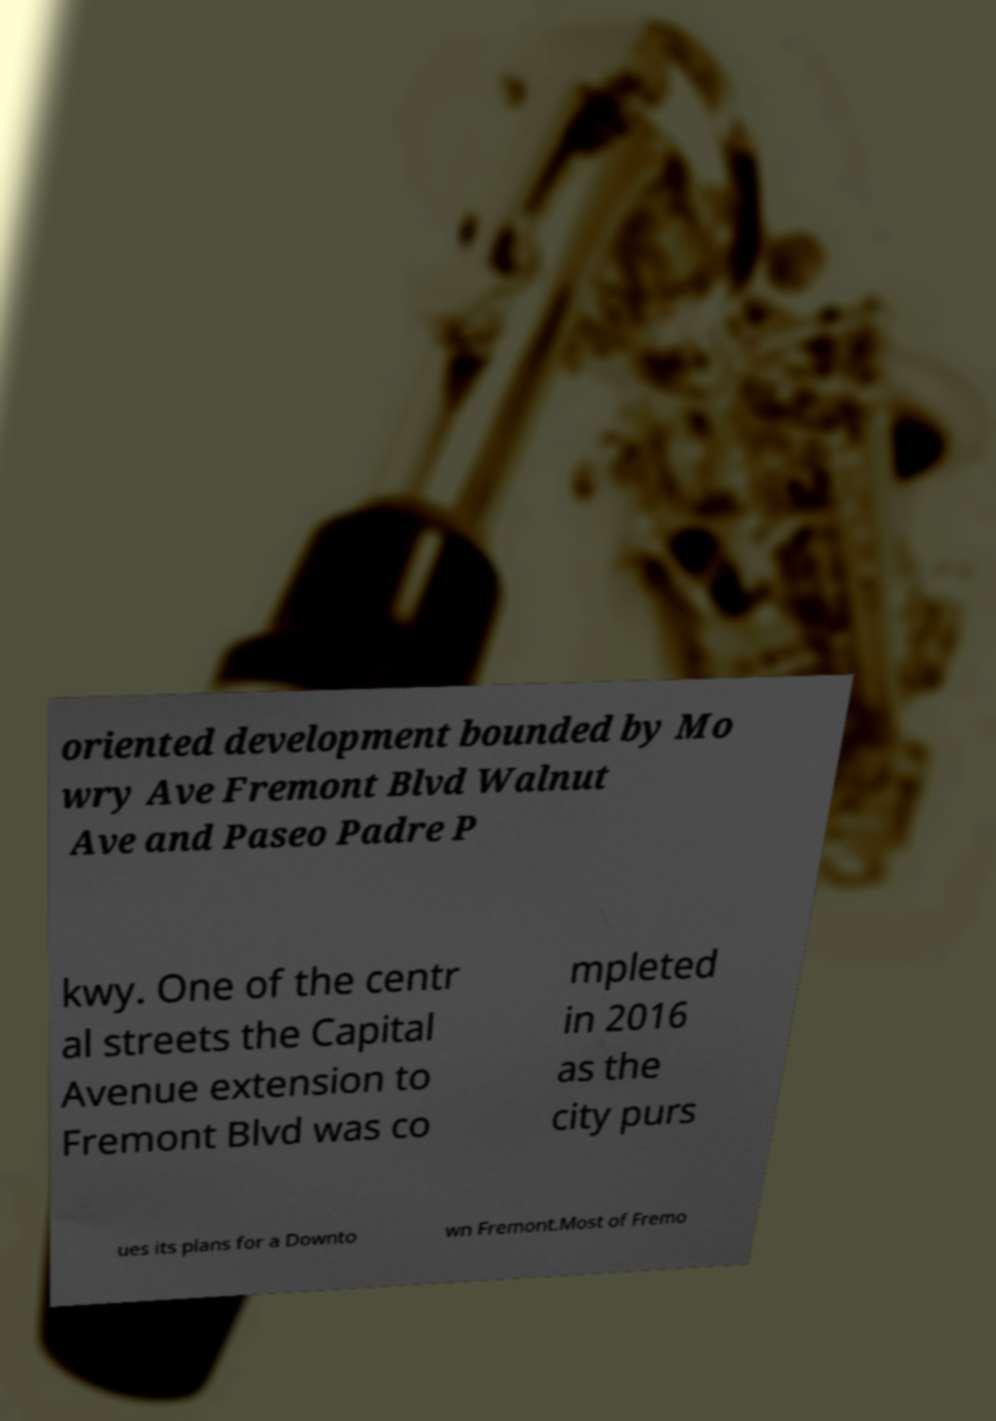What messages or text are displayed in this image? I need them in a readable, typed format. oriented development bounded by Mo wry Ave Fremont Blvd Walnut Ave and Paseo Padre P kwy. One of the centr al streets the Capital Avenue extension to Fremont Blvd was co mpleted in 2016 as the city purs ues its plans for a Downto wn Fremont.Most of Fremo 